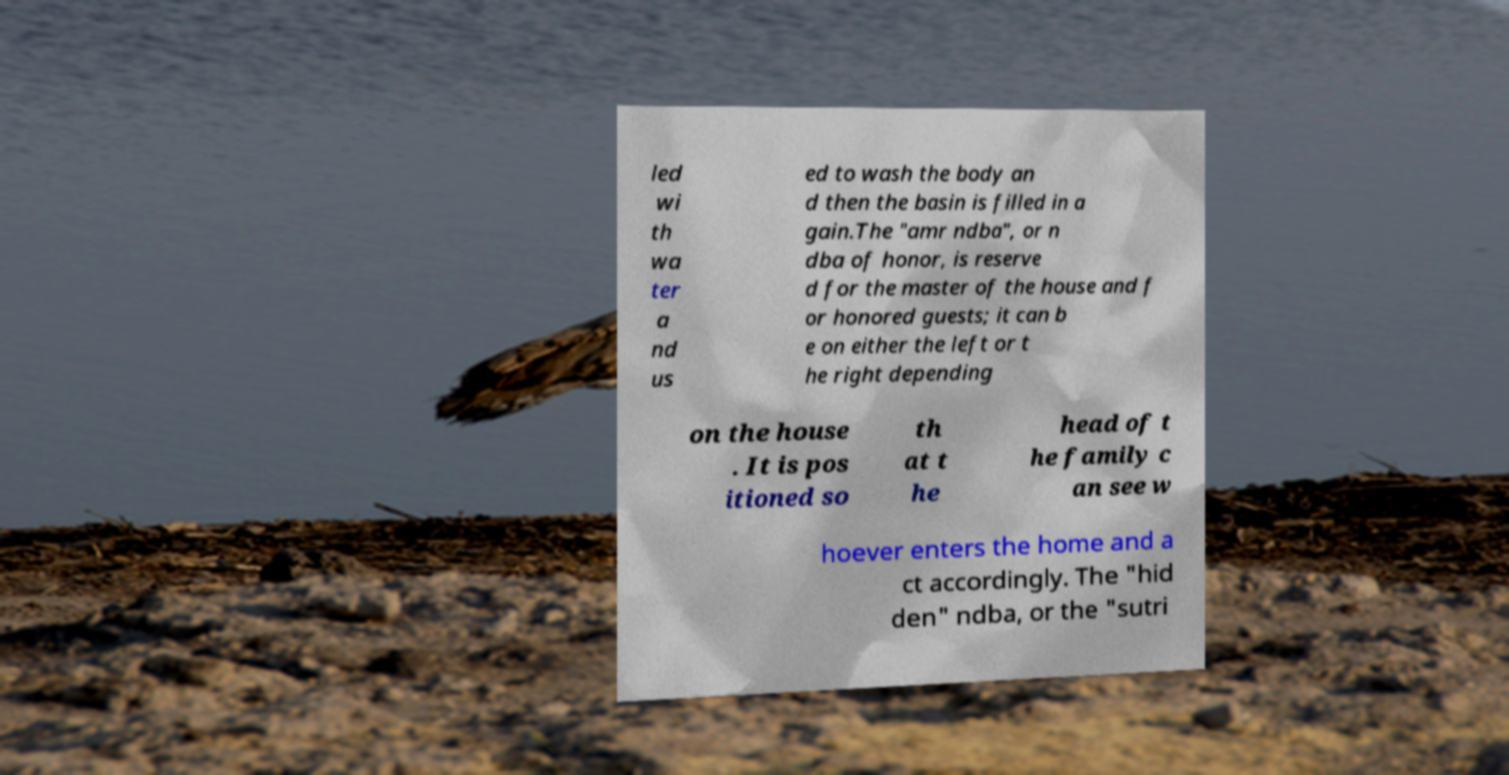There's text embedded in this image that I need extracted. Can you transcribe it verbatim? led wi th wa ter a nd us ed to wash the body an d then the basin is filled in a gain.The "amr ndba", or n dba of honor, is reserve d for the master of the house and f or honored guests; it can b e on either the left or t he right depending on the house . It is pos itioned so th at t he head of t he family c an see w hoever enters the home and a ct accordingly. The "hid den" ndba, or the "sutri 